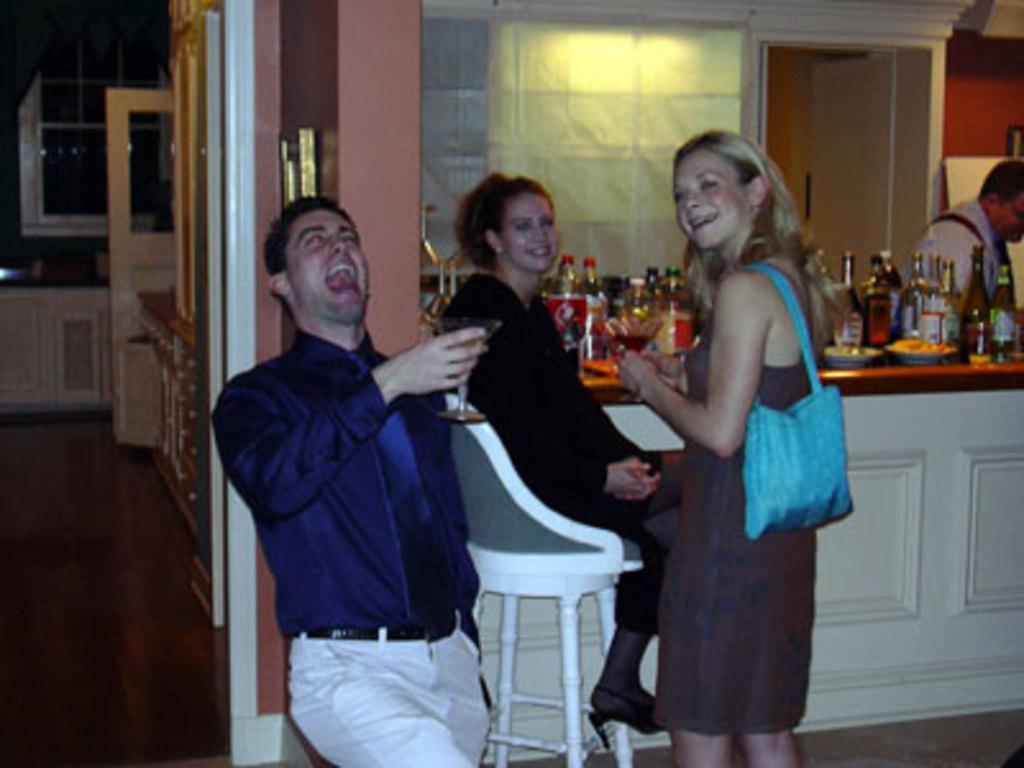Could you give a brief overview of what you see in this image? In the image there is a man in navy blue shirt holding a wine glass and smiling and beside there is a woman sitting on chair and another woman standing in front of table with wine bottles on it, and over the back there is wall and doors on the left side. 